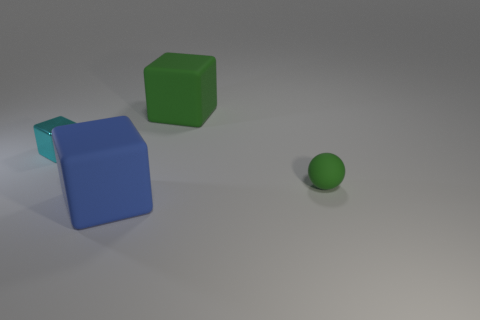What color is the cube in front of the green thing that is in front of the tiny cyan metal thing?
Your answer should be very brief. Blue. What number of objects are either green matte things that are in front of the tiny cyan shiny cube or tiny cyan rubber things?
Keep it short and to the point. 1. There is a metal thing; is its size the same as the matte thing that is behind the tiny green thing?
Offer a very short reply. No. How many large things are either green matte spheres or purple cubes?
Your response must be concise. 0. The blue rubber object has what shape?
Ensure brevity in your answer.  Cube. There is a block that is the same color as the sphere; what size is it?
Ensure brevity in your answer.  Large. Are there any blue objects that have the same material as the large green block?
Your answer should be very brief. Yes. Is the number of big blue rubber blocks greater than the number of red metal blocks?
Your answer should be compact. Yes. Does the blue object have the same material as the cyan thing?
Your response must be concise. No. What number of matte things are either small red objects or green spheres?
Offer a terse response. 1. 